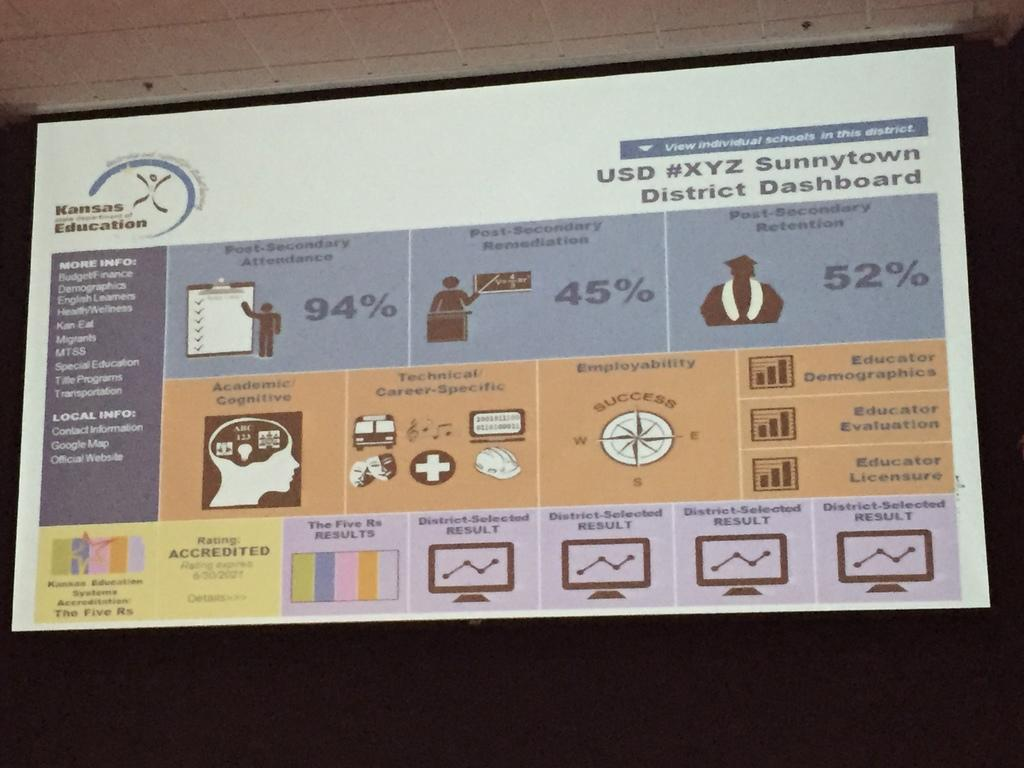Provide a one-sentence caption for the provided image. Statistics on a board displayed by the Sunnytown District. 